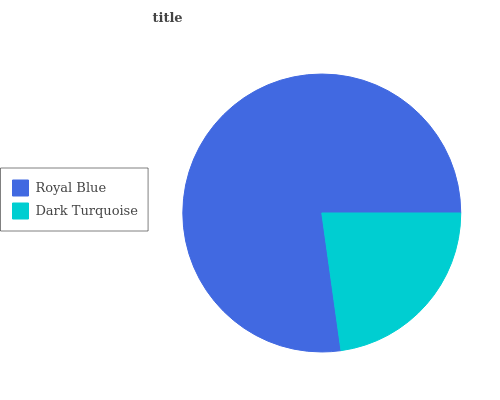Is Dark Turquoise the minimum?
Answer yes or no. Yes. Is Royal Blue the maximum?
Answer yes or no. Yes. Is Dark Turquoise the maximum?
Answer yes or no. No. Is Royal Blue greater than Dark Turquoise?
Answer yes or no. Yes. Is Dark Turquoise less than Royal Blue?
Answer yes or no. Yes. Is Dark Turquoise greater than Royal Blue?
Answer yes or no. No. Is Royal Blue less than Dark Turquoise?
Answer yes or no. No. Is Royal Blue the high median?
Answer yes or no. Yes. Is Dark Turquoise the low median?
Answer yes or no. Yes. Is Dark Turquoise the high median?
Answer yes or no. No. Is Royal Blue the low median?
Answer yes or no. No. 